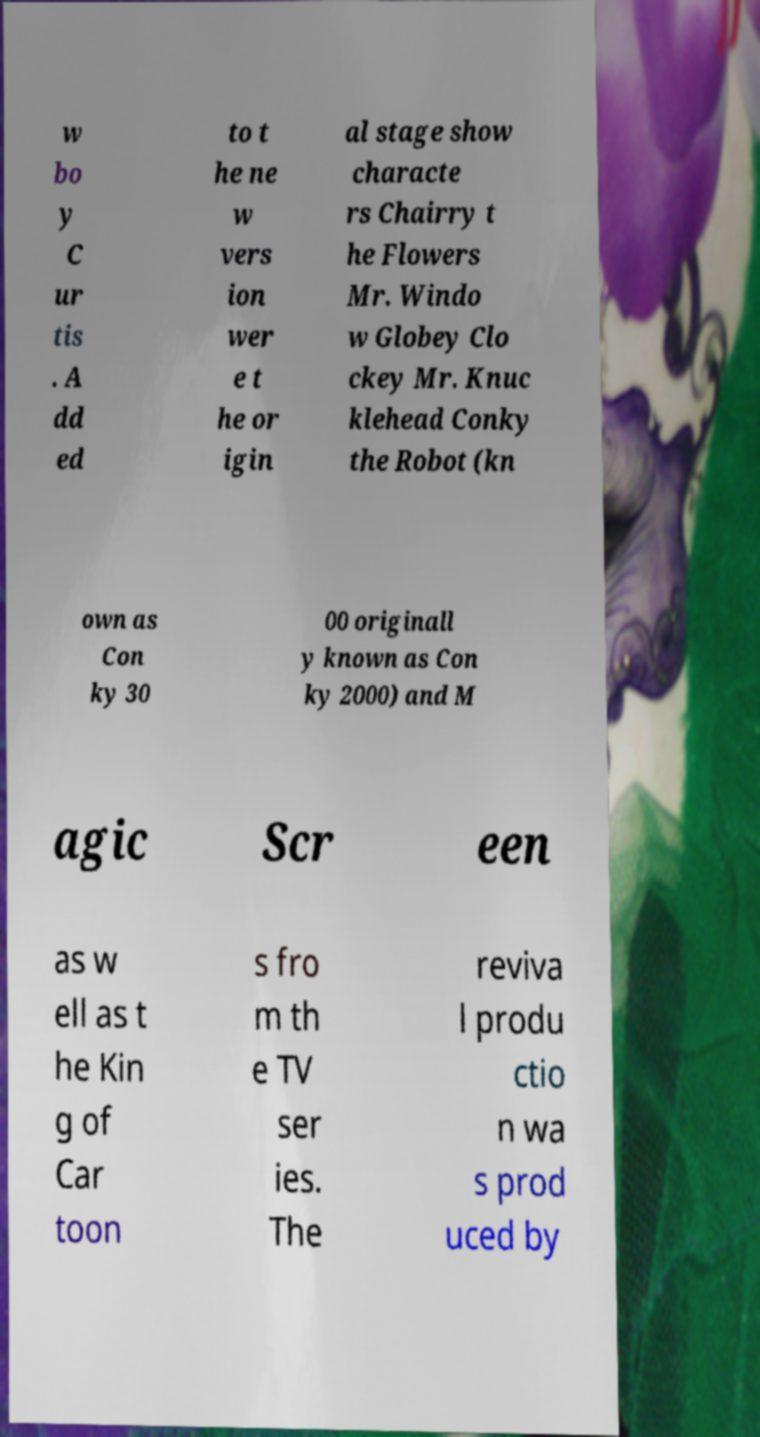I need the written content from this picture converted into text. Can you do that? w bo y C ur tis . A dd ed to t he ne w vers ion wer e t he or igin al stage show characte rs Chairry t he Flowers Mr. Windo w Globey Clo ckey Mr. Knuc klehead Conky the Robot (kn own as Con ky 30 00 originall y known as Con ky 2000) and M agic Scr een as w ell as t he Kin g of Car toon s fro m th e TV ser ies. The reviva l produ ctio n wa s prod uced by 